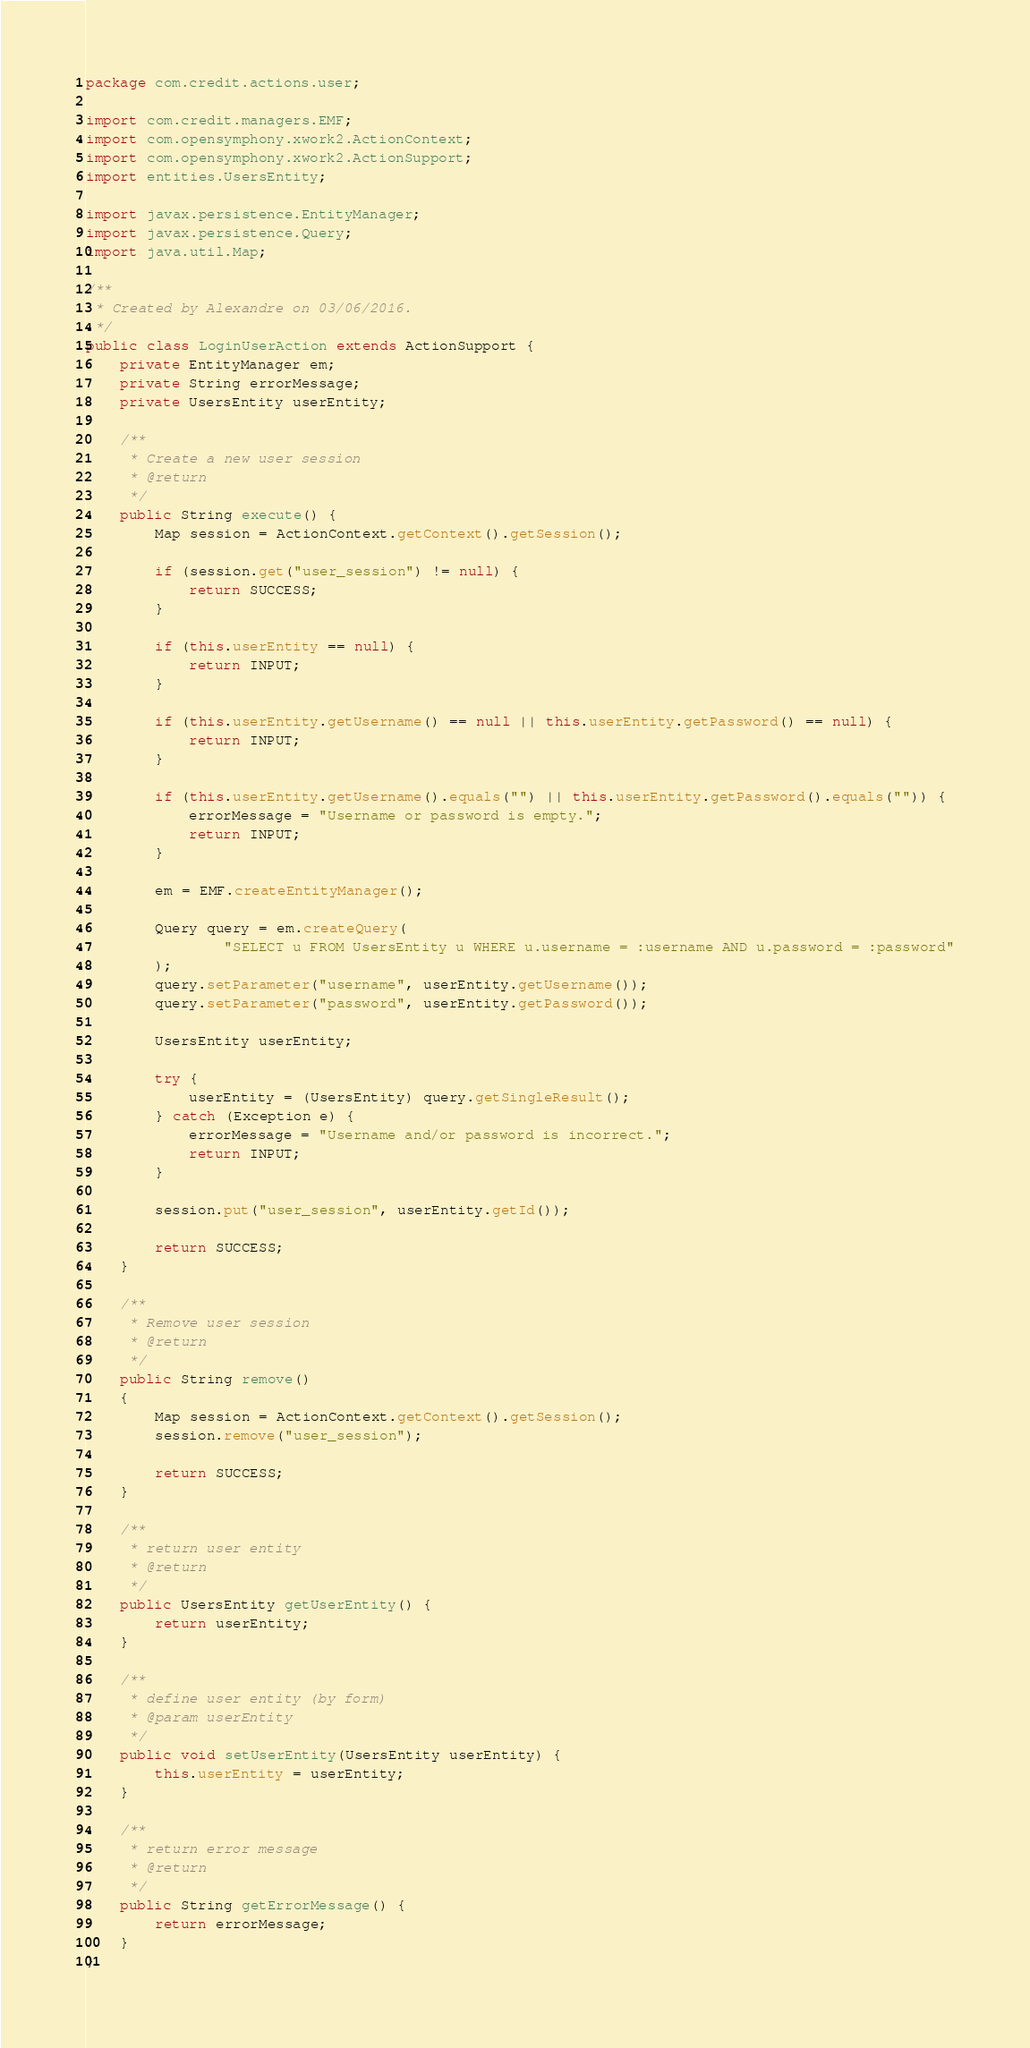<code> <loc_0><loc_0><loc_500><loc_500><_Java_>package com.credit.actions.user;

import com.credit.managers.EMF;
import com.opensymphony.xwork2.ActionContext;
import com.opensymphony.xwork2.ActionSupport;
import entities.UsersEntity;

import javax.persistence.EntityManager;
import javax.persistence.Query;
import java.util.Map;

/**
 * Created by Alexandre on 03/06/2016.
 */
public class LoginUserAction extends ActionSupport {
    private EntityManager em;
    private String errorMessage;
    private UsersEntity userEntity;

    /**
     * Create a new user session
     * @return
     */
    public String execute() {
        Map session = ActionContext.getContext().getSession();

        if (session.get("user_session") != null) {
            return SUCCESS;
        }

        if (this.userEntity == null) {
            return INPUT;
        }

        if (this.userEntity.getUsername() == null || this.userEntity.getPassword() == null) {
            return INPUT;
        }

        if (this.userEntity.getUsername().equals("") || this.userEntity.getPassword().equals("")) {
            errorMessage = "Username or password is empty.";
            return INPUT;
        }

        em = EMF.createEntityManager();

        Query query = em.createQuery(
                "SELECT u FROM UsersEntity u WHERE u.username = :username AND u.password = :password"
        );
        query.setParameter("username", userEntity.getUsername());
        query.setParameter("password", userEntity.getPassword());

        UsersEntity userEntity;

        try {
            userEntity = (UsersEntity) query.getSingleResult();
        } catch (Exception e) {
            errorMessage = "Username and/or password is incorrect.";
            return INPUT;
        }

        session.put("user_session", userEntity.getId());

        return SUCCESS;
    }

    /**
     * Remove user session
     * @return
     */
    public String remove()
    {
        Map session = ActionContext.getContext().getSession();
        session.remove("user_session");

        return SUCCESS;
    }

    /**
     * return user entity
     * @return
     */
    public UsersEntity getUserEntity() {
        return userEntity;
    }

    /**
     * define user entity (by form)
     * @param userEntity
     */
    public void setUserEntity(UsersEntity userEntity) {
        this.userEntity = userEntity;
    }

    /**
     * return error message
     * @return
     */
    public String getErrorMessage() {
        return errorMessage;
    }
}
</code> 